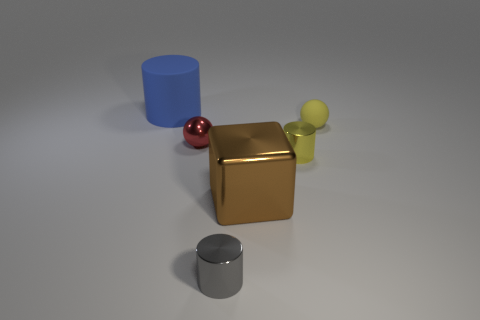Add 1 small yellow metal balls. How many objects exist? 7 Subtract all balls. How many objects are left? 4 Add 6 metal balls. How many metal balls are left? 7 Add 2 tiny purple rubber cubes. How many tiny purple rubber cubes exist? 2 Subtract 0 purple balls. How many objects are left? 6 Subtract all tiny red objects. Subtract all red rubber cylinders. How many objects are left? 5 